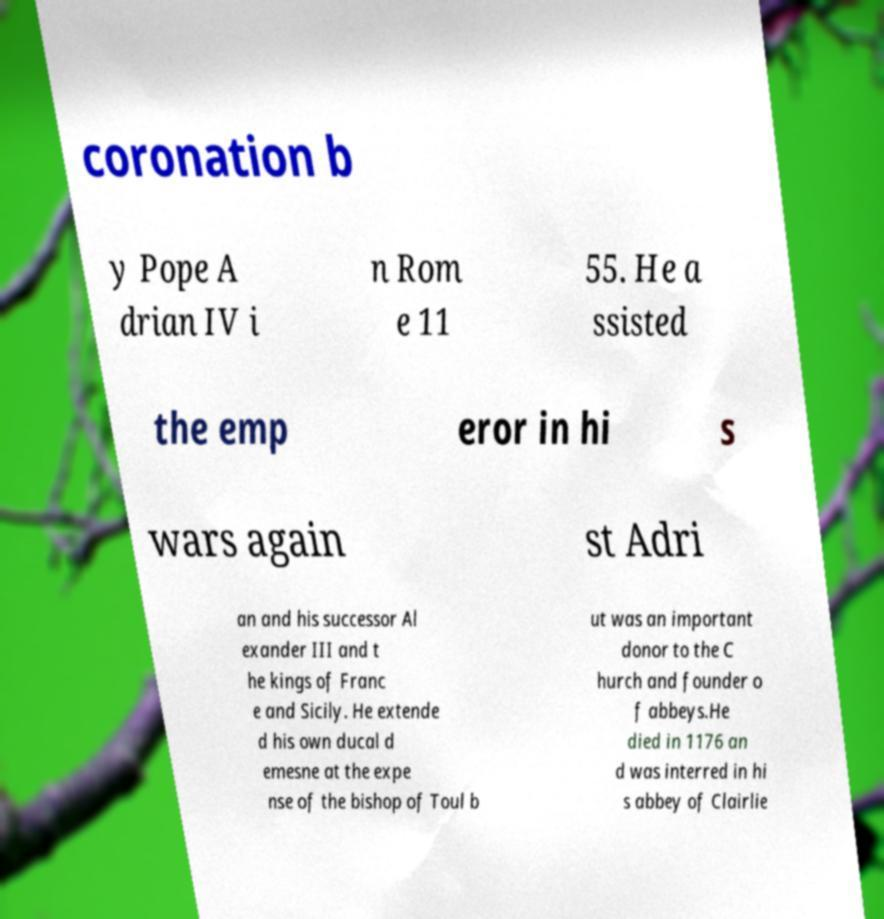Can you accurately transcribe the text from the provided image for me? coronation b y Pope A drian IV i n Rom e 11 55. He a ssisted the emp eror in hi s wars again st Adri an and his successor Al exander III and t he kings of Franc e and Sicily. He extende d his own ducal d emesne at the expe nse of the bishop of Toul b ut was an important donor to the C hurch and founder o f abbeys.He died in 1176 an d was interred in hi s abbey of Clairlie 